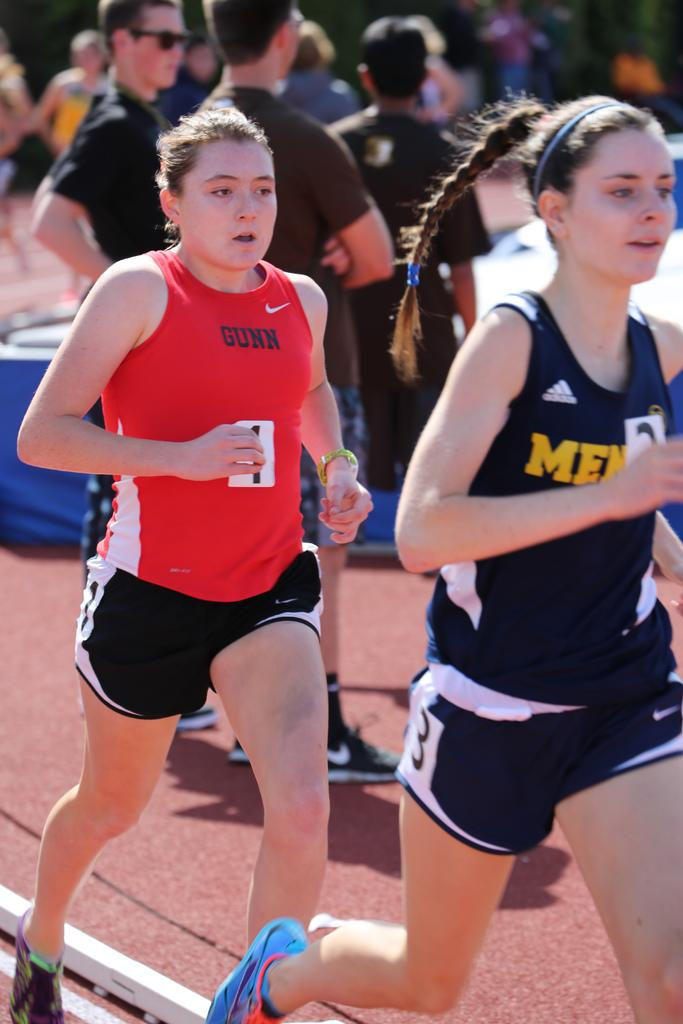<image>
Summarize the visual content of the image. A runner in an orange jersey is labeled with Gunn. 